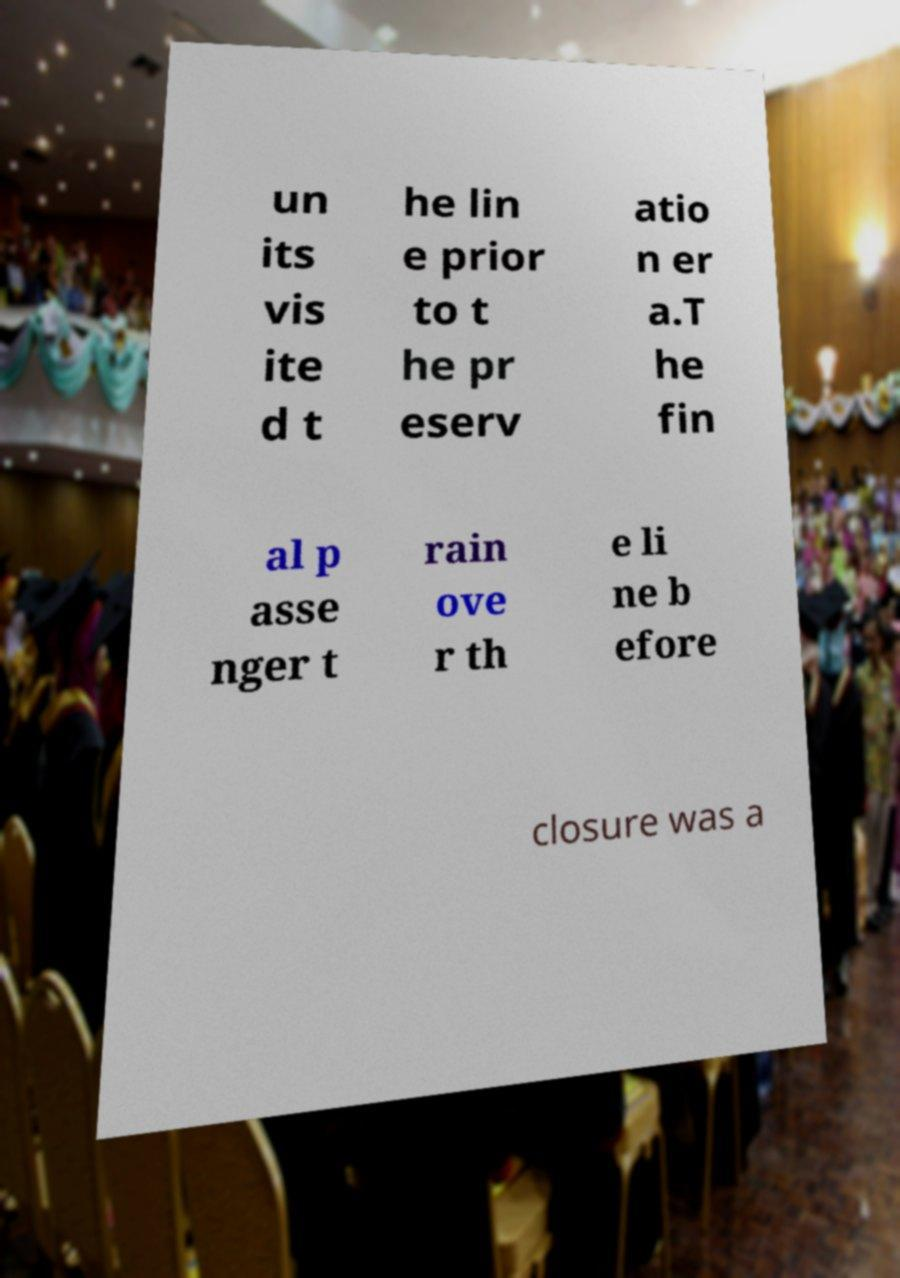Please identify and transcribe the text found in this image. un its vis ite d t he lin e prior to t he pr eserv atio n er a.T he fin al p asse nger t rain ove r th e li ne b efore closure was a 